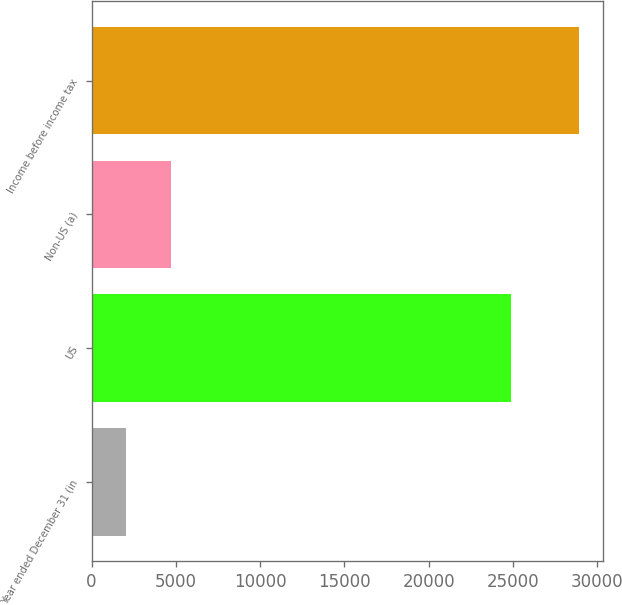Convert chart to OTSL. <chart><loc_0><loc_0><loc_500><loc_500><bar_chart><fcel>Year ended December 31 (in<fcel>US<fcel>Non-US (a)<fcel>Income before income tax<nl><fcel>2012<fcel>24895<fcel>4702.5<fcel>28917<nl></chart> 